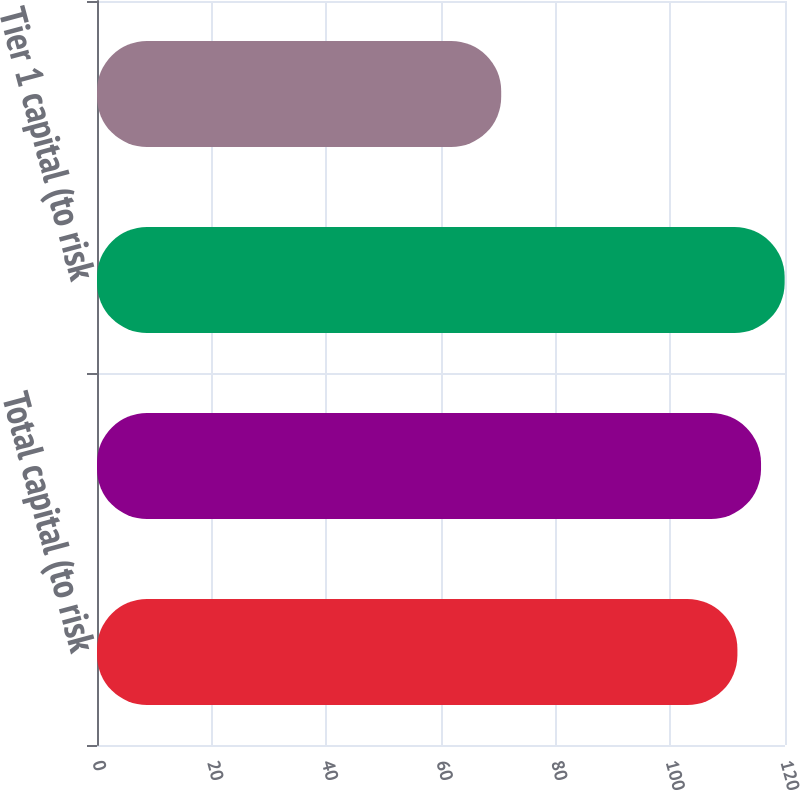Convert chart. <chart><loc_0><loc_0><loc_500><loc_500><bar_chart><fcel>Total capital (to risk<fcel>Common Equity Tier 1 capital<fcel>Tier 1 capital (to risk<fcel>Tier 1 capital (to average<nl><fcel>111.7<fcel>115.82<fcel>119.94<fcel>70.5<nl></chart> 